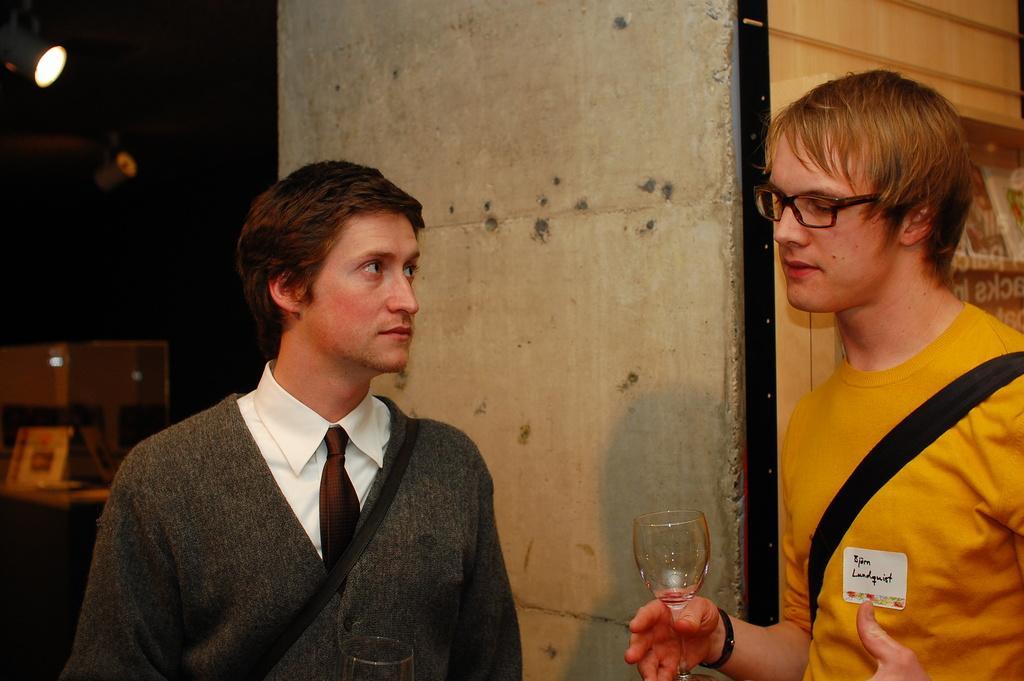Could you give a brief overview of what you see in this image? In this image there are persons standing. On the right side there is a man standing and holding a glass in his hand. In the background there is a wall and there are lights and there are objects which are white in colour. 